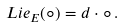<formula> <loc_0><loc_0><loc_500><loc_500>L i e _ { E } ( \circ ) = d \cdot \circ \, .</formula> 